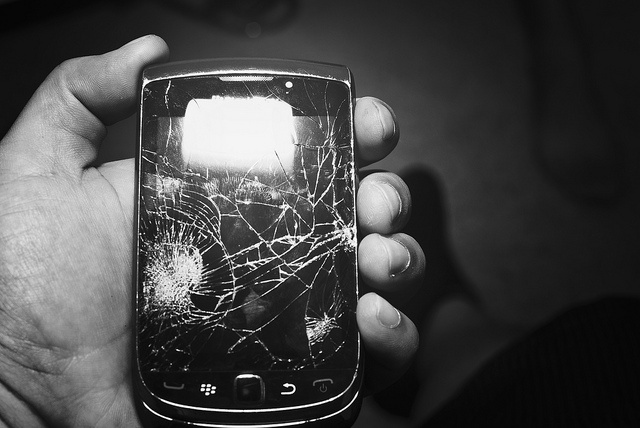Describe the objects in this image and their specific colors. I can see cell phone in black, gray, white, and darkgray tones and people in black, darkgray, gray, and lightgray tones in this image. 